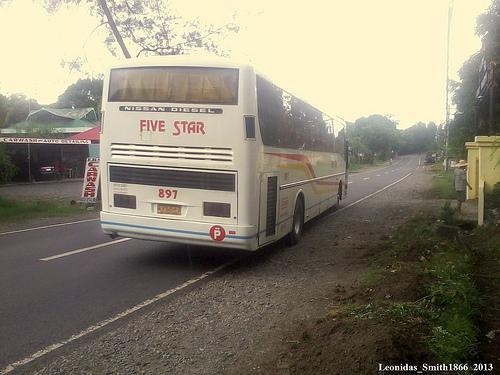How many buses are there?
Give a very brief answer. 1. 